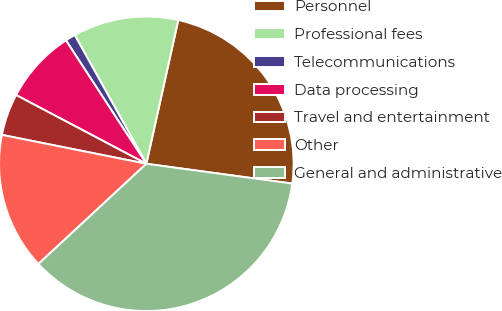Convert chart to OTSL. <chart><loc_0><loc_0><loc_500><loc_500><pie_chart><fcel>Personnel<fcel>Professional fees<fcel>Telecommunications<fcel>Data processing<fcel>Travel and entertainment<fcel>Other<fcel>General and administrative<nl><fcel>23.67%<fcel>11.56%<fcel>1.11%<fcel>8.08%<fcel>4.59%<fcel>15.05%<fcel>35.95%<nl></chart> 